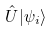<formula> <loc_0><loc_0><loc_500><loc_500>\hat { U } | \psi _ { i } \rangle</formula> 